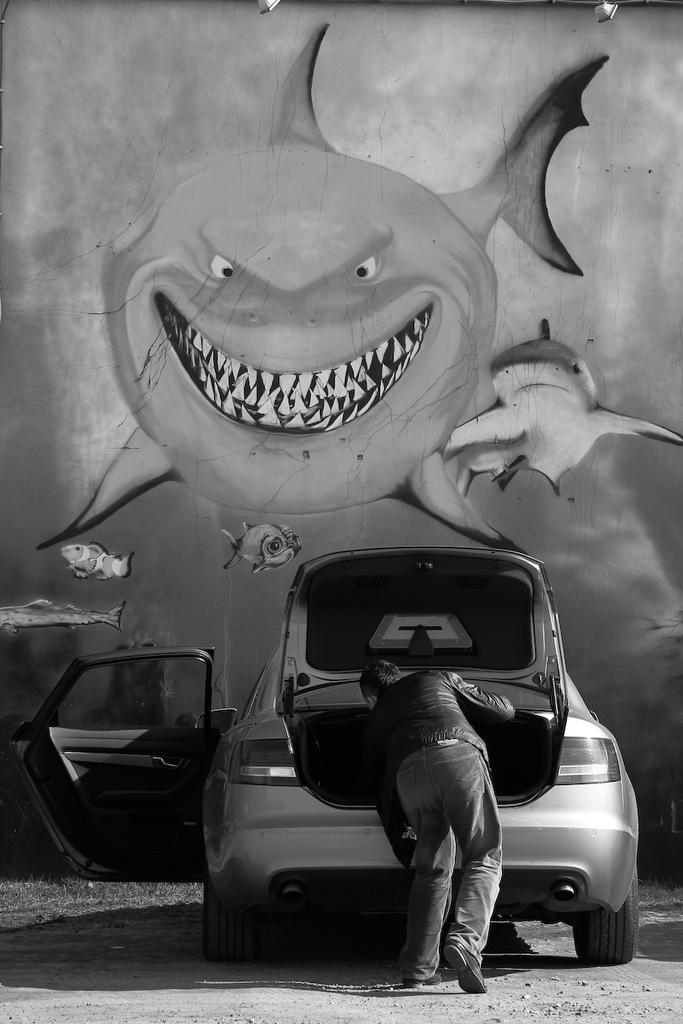Could you give a brief overview of what you see in this image? In this image I can see the person standing in-front of the vehicle. In the background I can see the wall painting and this is a black and white image. 